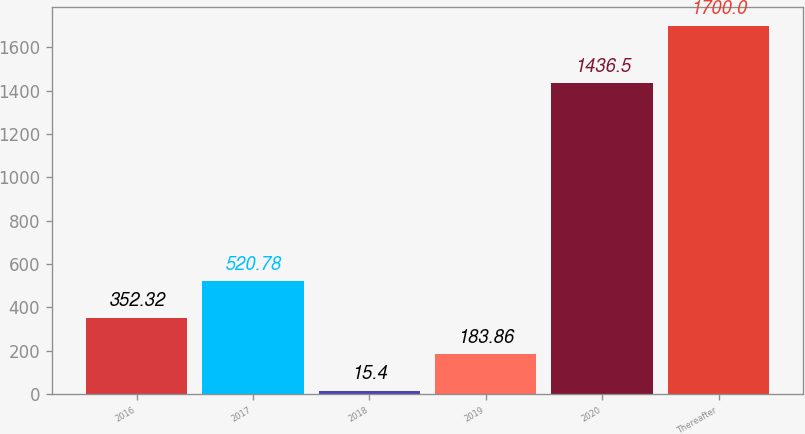Convert chart to OTSL. <chart><loc_0><loc_0><loc_500><loc_500><bar_chart><fcel>2016<fcel>2017<fcel>2018<fcel>2019<fcel>2020<fcel>Thereafter<nl><fcel>352.32<fcel>520.78<fcel>15.4<fcel>183.86<fcel>1436.5<fcel>1700<nl></chart> 